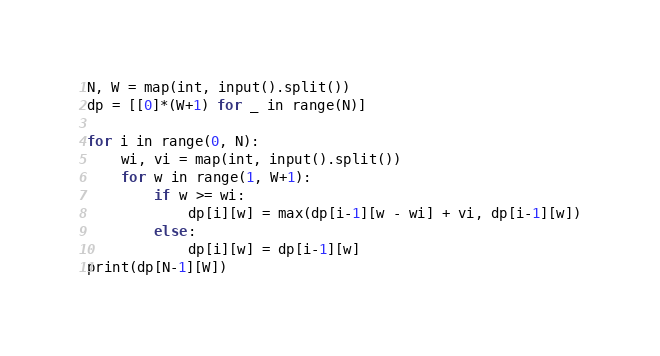<code> <loc_0><loc_0><loc_500><loc_500><_Python_>N, W = map(int, input().split())
dp = [[0]*(W+1) for _ in range(N)]

for i in range(0, N):
    wi, vi = map(int, input().split())
    for w in range(1, W+1):
        if w >= wi:
            dp[i][w] = max(dp[i-1][w - wi] + vi, dp[i-1][w])
        else:
            dp[i][w] = dp[i-1][w]
print(dp[N-1][W])</code> 